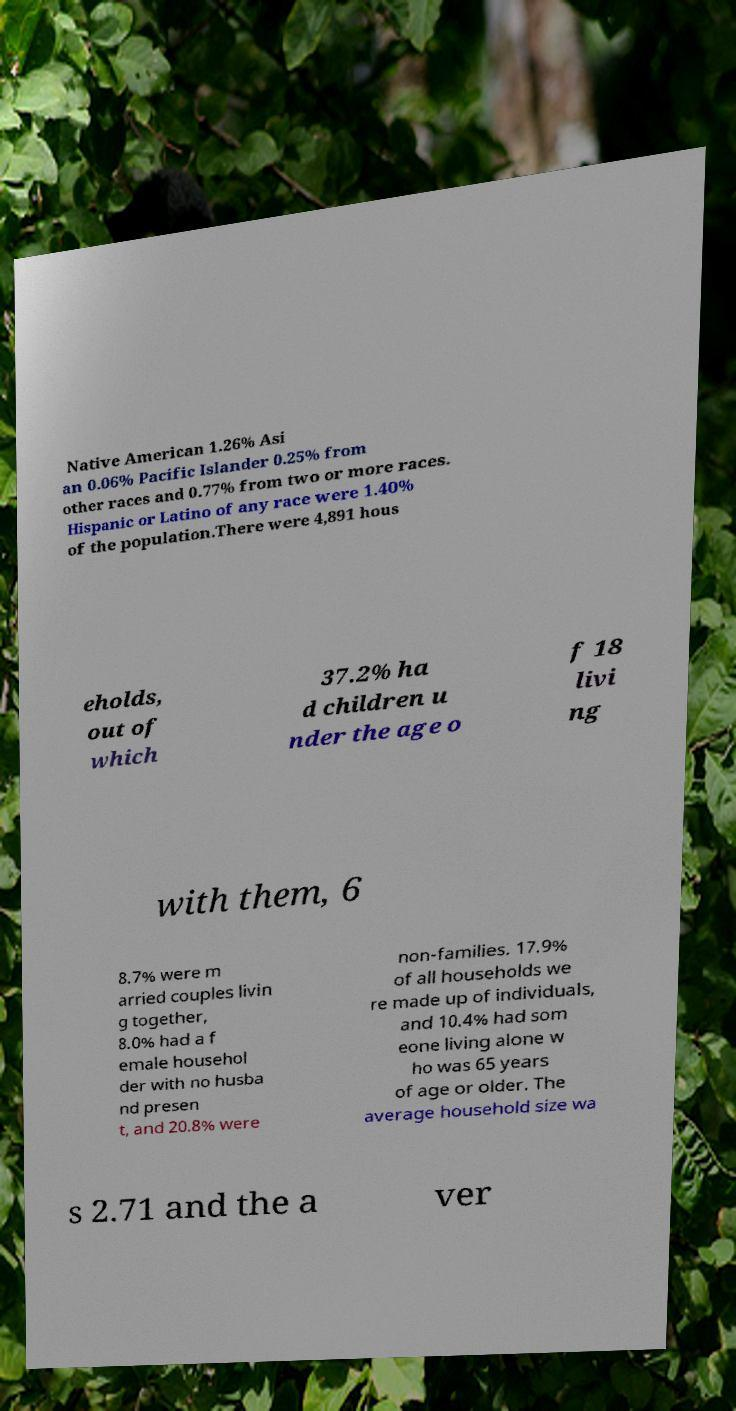There's text embedded in this image that I need extracted. Can you transcribe it verbatim? Native American 1.26% Asi an 0.06% Pacific Islander 0.25% from other races and 0.77% from two or more races. Hispanic or Latino of any race were 1.40% of the population.There were 4,891 hous eholds, out of which 37.2% ha d children u nder the age o f 18 livi ng with them, 6 8.7% were m arried couples livin g together, 8.0% had a f emale househol der with no husba nd presen t, and 20.8% were non-families. 17.9% of all households we re made up of individuals, and 10.4% had som eone living alone w ho was 65 years of age or older. The average household size wa s 2.71 and the a ver 